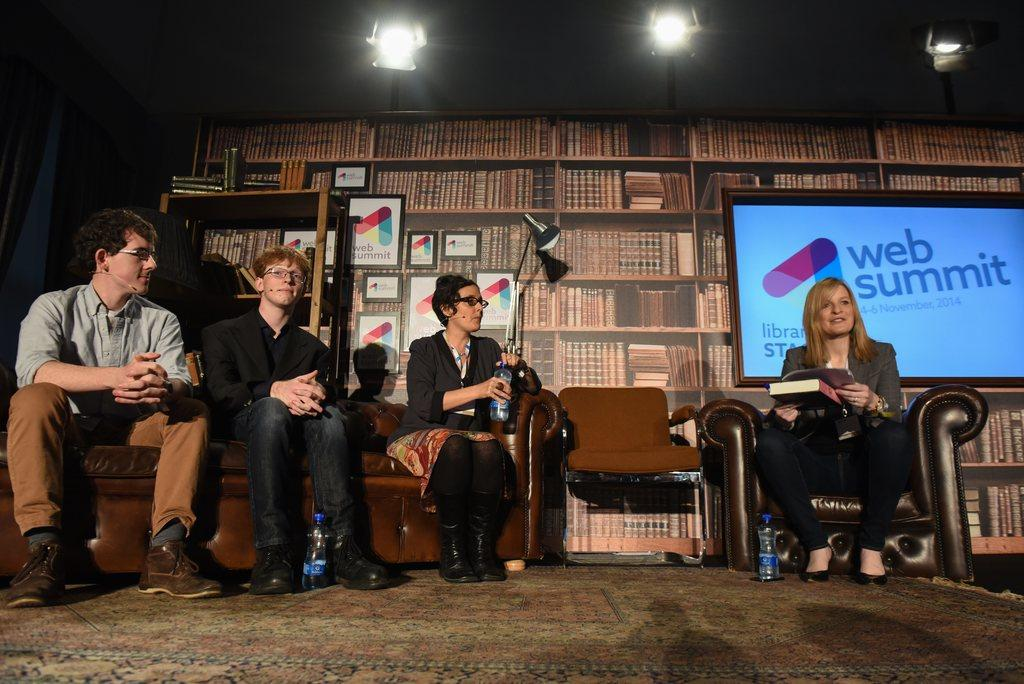How many people are sitting on the sofas in the image? There are four people sitting on the sofas in the image. What can be seen behind the people sitting on the sofas? There are books and frames behind the people. What type of lighting is present in the image? There is a lamp in the image. What is displayed on the screen beside the lamp? A screen displaying a picture is present beside the lamp. How much payment is required to enter the room in the image? There is no indication of payment or entering a room in the image; it simply shows four people sitting on sofas with other objects around them. 